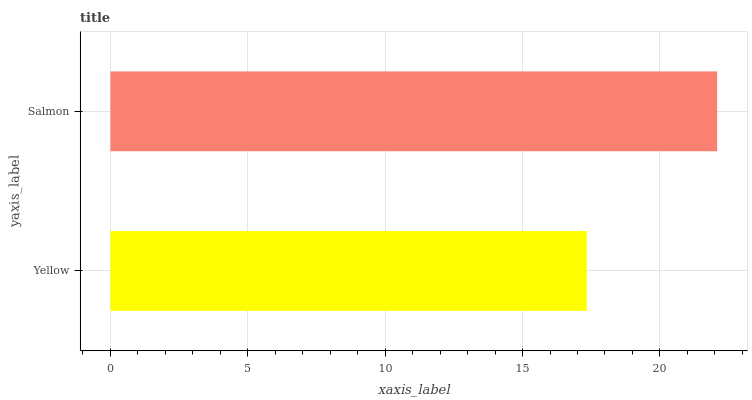Is Yellow the minimum?
Answer yes or no. Yes. Is Salmon the maximum?
Answer yes or no. Yes. Is Salmon the minimum?
Answer yes or no. No. Is Salmon greater than Yellow?
Answer yes or no. Yes. Is Yellow less than Salmon?
Answer yes or no. Yes. Is Yellow greater than Salmon?
Answer yes or no. No. Is Salmon less than Yellow?
Answer yes or no. No. Is Salmon the high median?
Answer yes or no. Yes. Is Yellow the low median?
Answer yes or no. Yes. Is Yellow the high median?
Answer yes or no. No. Is Salmon the low median?
Answer yes or no. No. 